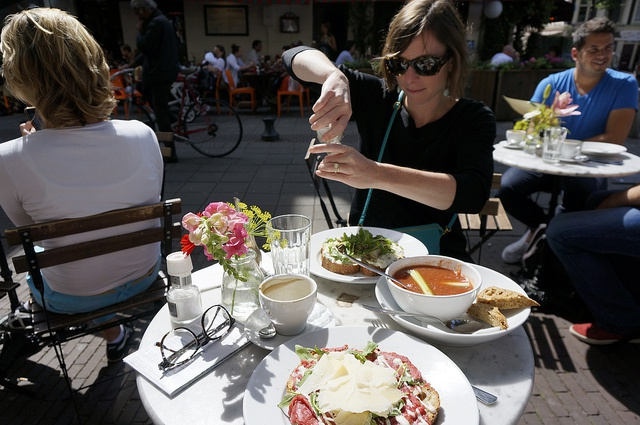Describe the objects in this image and their specific colors. I can see dining table in black, lightgray, darkgray, and gray tones, people in black, brown, and gray tones, people in black and gray tones, chair in black, gray, darkblue, and blue tones, and people in black, navy, maroon, and gray tones in this image. 